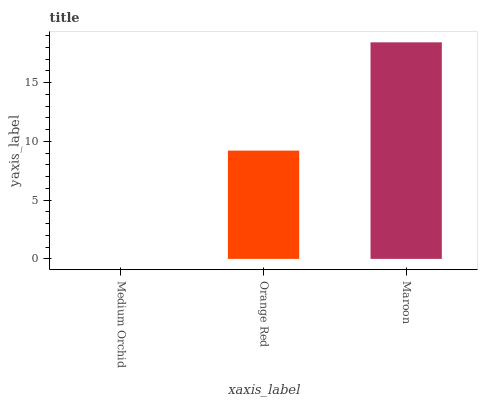Is Medium Orchid the minimum?
Answer yes or no. Yes. Is Maroon the maximum?
Answer yes or no. Yes. Is Orange Red the minimum?
Answer yes or no. No. Is Orange Red the maximum?
Answer yes or no. No. Is Orange Red greater than Medium Orchid?
Answer yes or no. Yes. Is Medium Orchid less than Orange Red?
Answer yes or no. Yes. Is Medium Orchid greater than Orange Red?
Answer yes or no. No. Is Orange Red less than Medium Orchid?
Answer yes or no. No. Is Orange Red the high median?
Answer yes or no. Yes. Is Orange Red the low median?
Answer yes or no. Yes. Is Medium Orchid the high median?
Answer yes or no. No. Is Medium Orchid the low median?
Answer yes or no. No. 